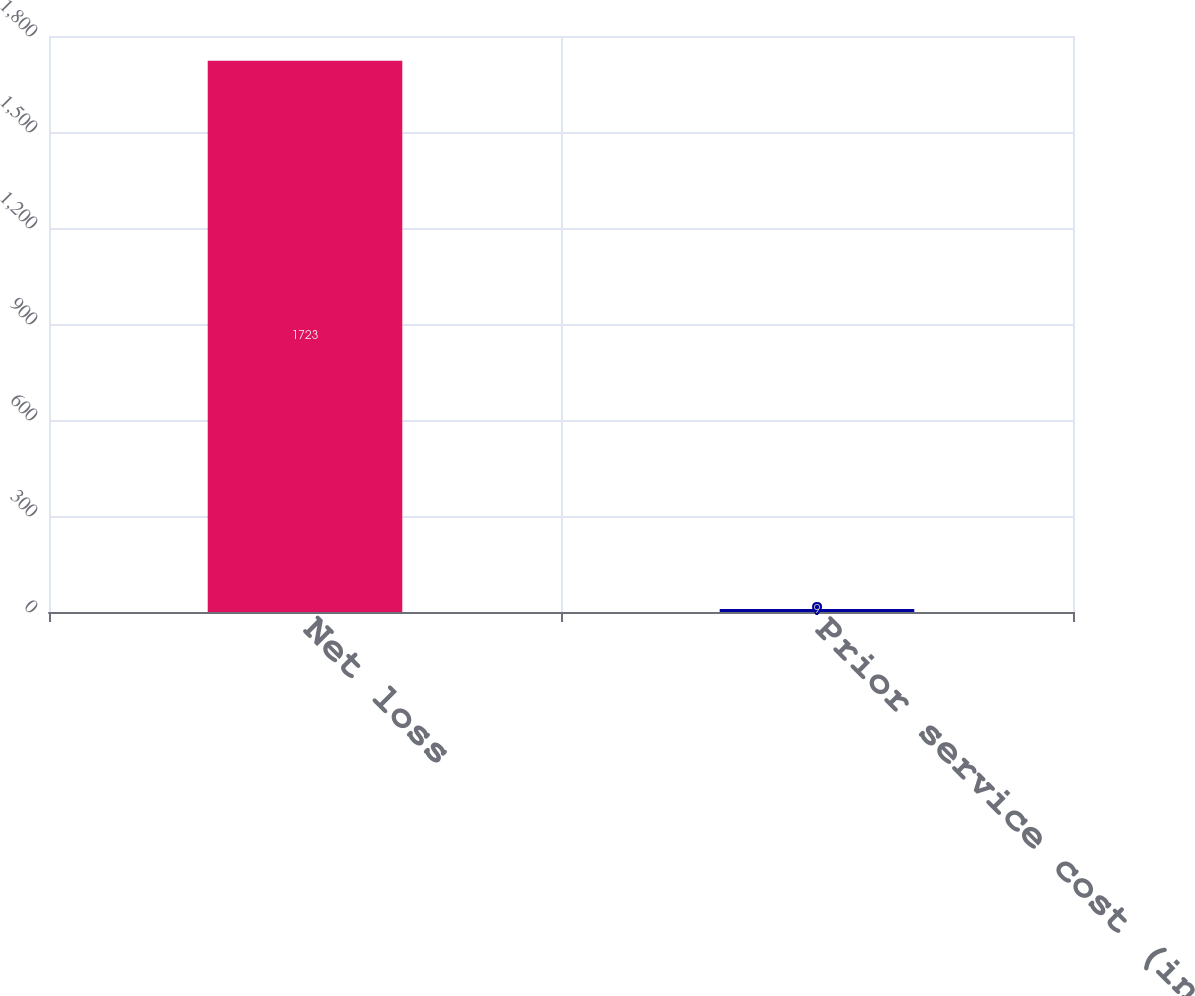Convert chart. <chart><loc_0><loc_0><loc_500><loc_500><bar_chart><fcel>Net loss<fcel>Prior service cost (income)<nl><fcel>1723<fcel>9<nl></chart> 